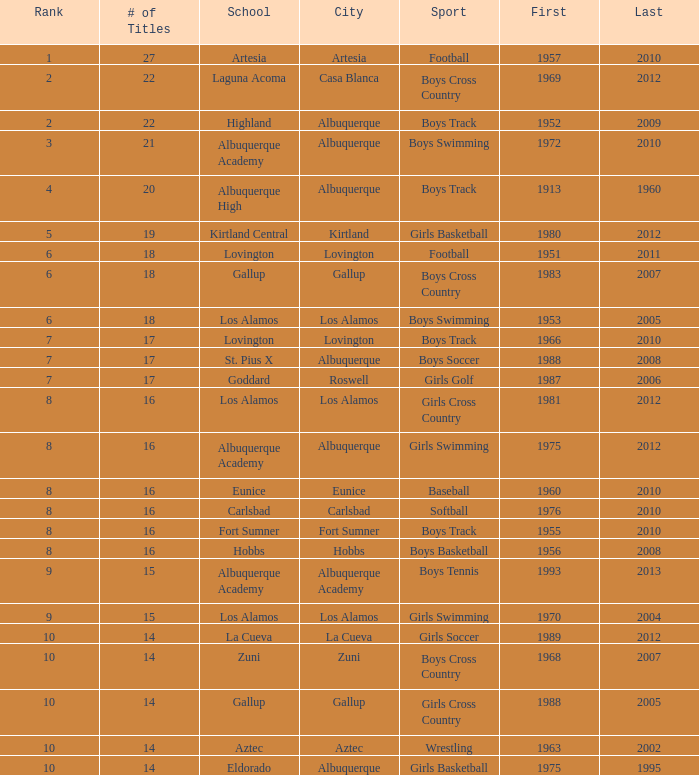In which city is the school, highland, located that holds a rank under 8 and won its initial title before 1980 and the latest one post 1960? Albuquerque. 